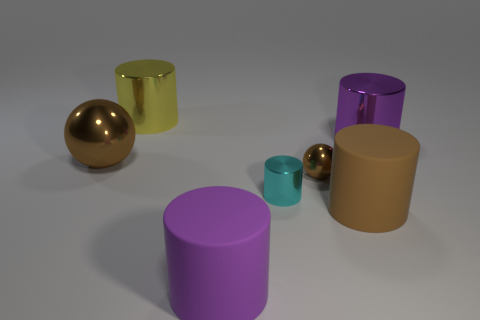Subtract 1 cylinders. How many cylinders are left? 4 Subtract all big purple cylinders. How many cylinders are left? 3 Subtract all purple cylinders. How many cylinders are left? 3 Add 1 tiny brown metallic objects. How many objects exist? 8 Subtract all red cylinders. Subtract all blue spheres. How many cylinders are left? 5 Subtract all spheres. How many objects are left? 5 Subtract all small shiny balls. Subtract all big purple metallic cylinders. How many objects are left? 5 Add 3 brown rubber cylinders. How many brown rubber cylinders are left? 4 Add 2 large purple metal things. How many large purple metal things exist? 3 Subtract 0 gray spheres. How many objects are left? 7 